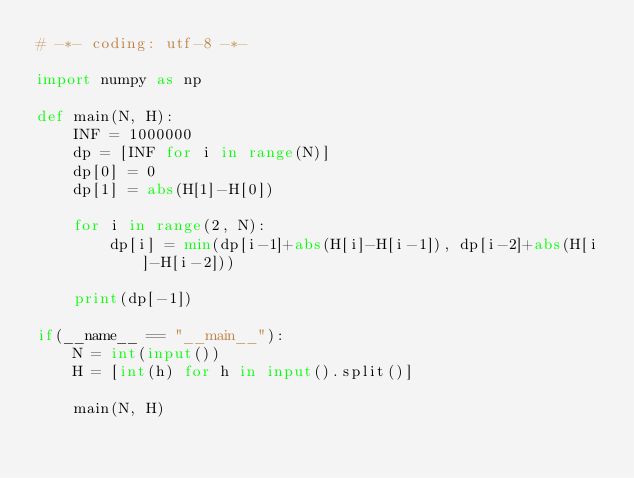<code> <loc_0><loc_0><loc_500><loc_500><_Python_># -*- coding: utf-8 -*-

import numpy as np
 
def main(N, H):
    INF = 1000000
    dp = [INF for i in range(N)]
    dp[0] = 0
    dp[1] = abs(H[1]-H[0])
    
    for i in range(2, N):
        dp[i] = min(dp[i-1]+abs(H[i]-H[i-1]), dp[i-2]+abs(H[i]-H[i-2]))
    
    print(dp[-1])
    
if(__name__ == "__main__"):
    N = int(input())
    H = [int(h) for h in input().split()]
    
    main(N, H)</code> 